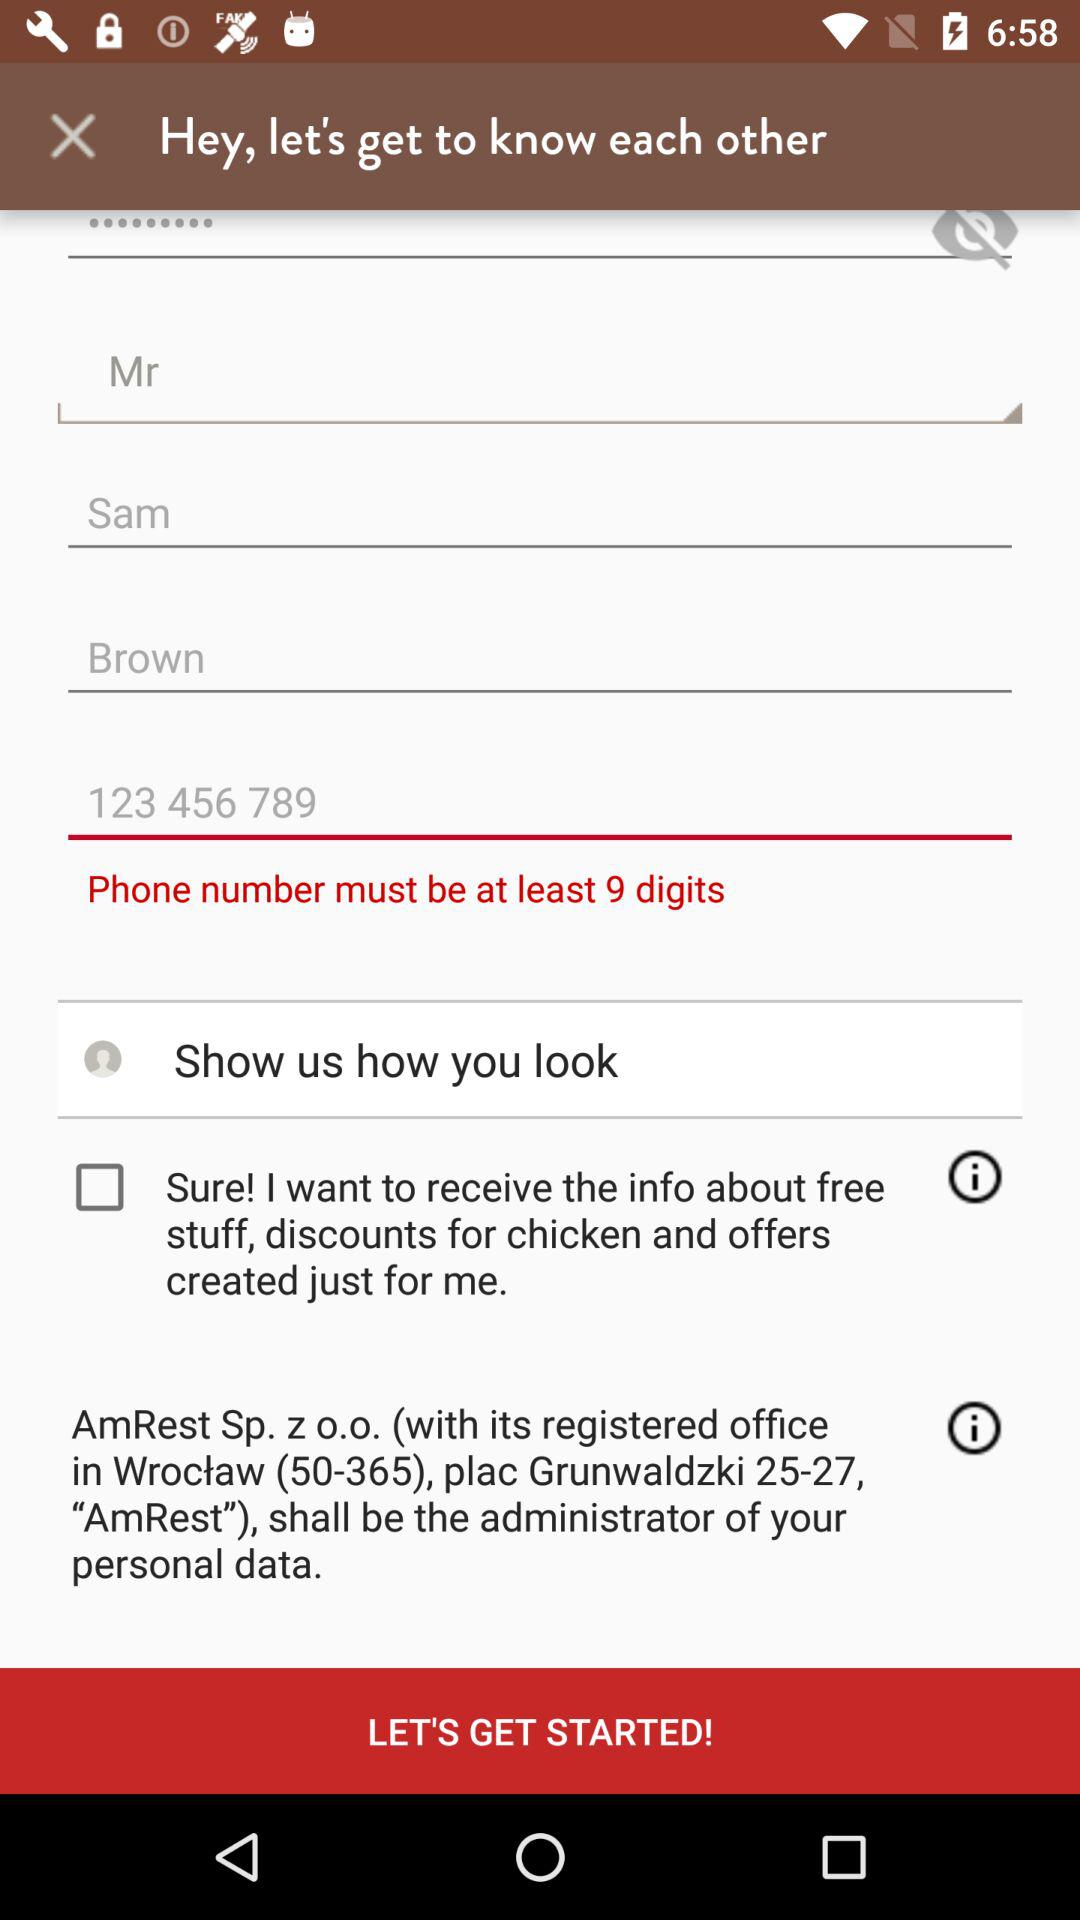What is the last name? The last name is Brown. 